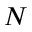Convert formula to latex. <formula><loc_0><loc_0><loc_500><loc_500>N</formula> 